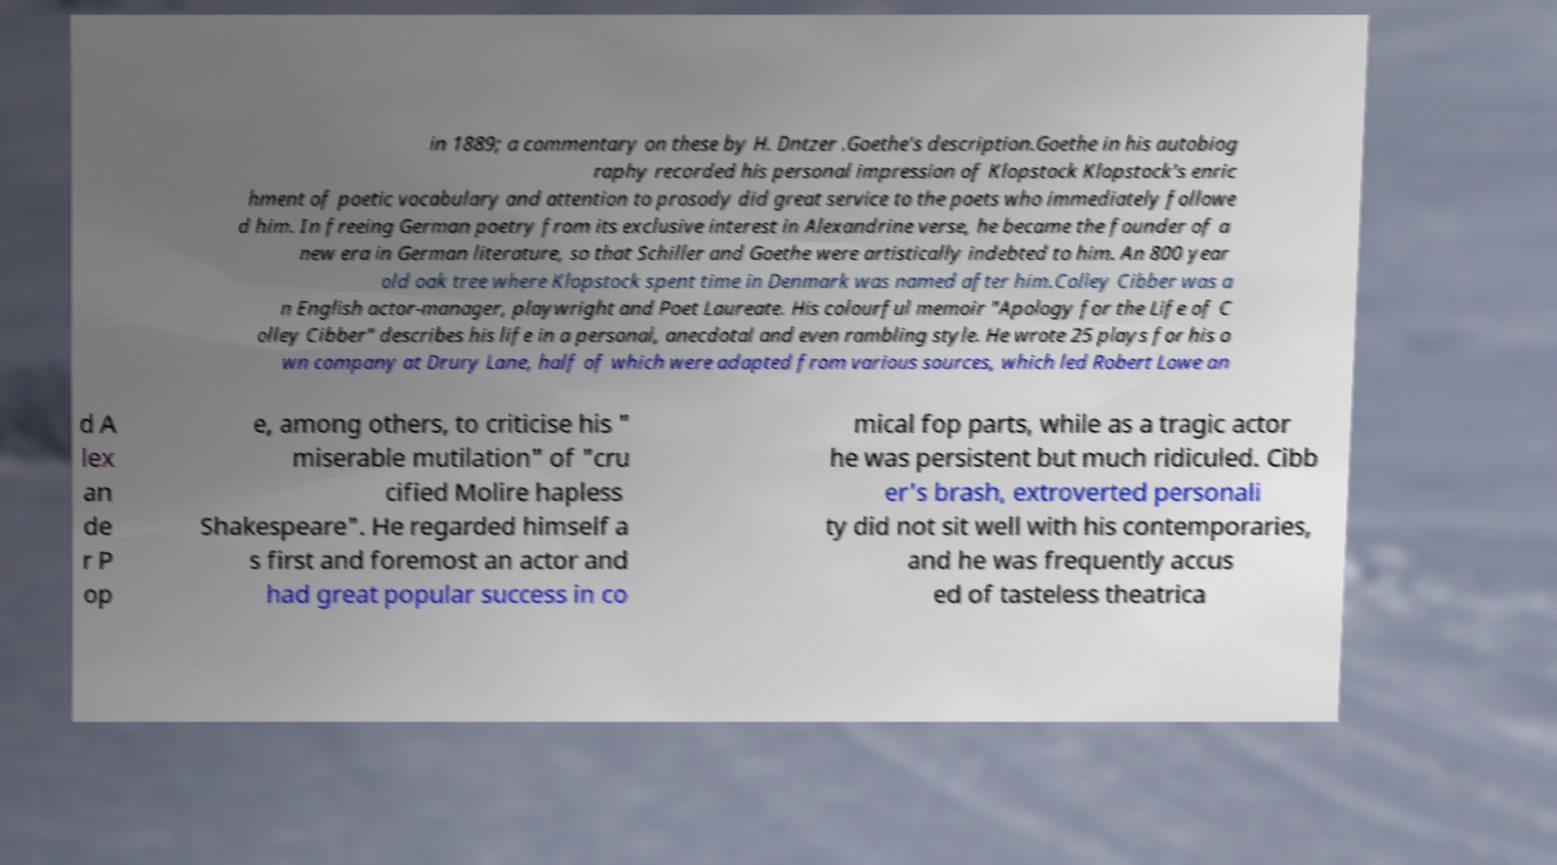Please identify and transcribe the text found in this image. in 1889; a commentary on these by H. Dntzer .Goethe's description.Goethe in his autobiog raphy recorded his personal impression of Klopstock Klopstock's enric hment of poetic vocabulary and attention to prosody did great service to the poets who immediately followe d him. In freeing German poetry from its exclusive interest in Alexandrine verse, he became the founder of a new era in German literature, so that Schiller and Goethe were artistically indebted to him. An 800 year old oak tree where Klopstock spent time in Denmark was named after him.Colley Cibber was a n English actor-manager, playwright and Poet Laureate. His colourful memoir "Apology for the Life of C olley Cibber" describes his life in a personal, anecdotal and even rambling style. He wrote 25 plays for his o wn company at Drury Lane, half of which were adapted from various sources, which led Robert Lowe an d A lex an de r P op e, among others, to criticise his " miserable mutilation" of "cru cified Molire hapless Shakespeare". He regarded himself a s first and foremost an actor and had great popular success in co mical fop parts, while as a tragic actor he was persistent but much ridiculed. Cibb er's brash, extroverted personali ty did not sit well with his contemporaries, and he was frequently accus ed of tasteless theatrica 